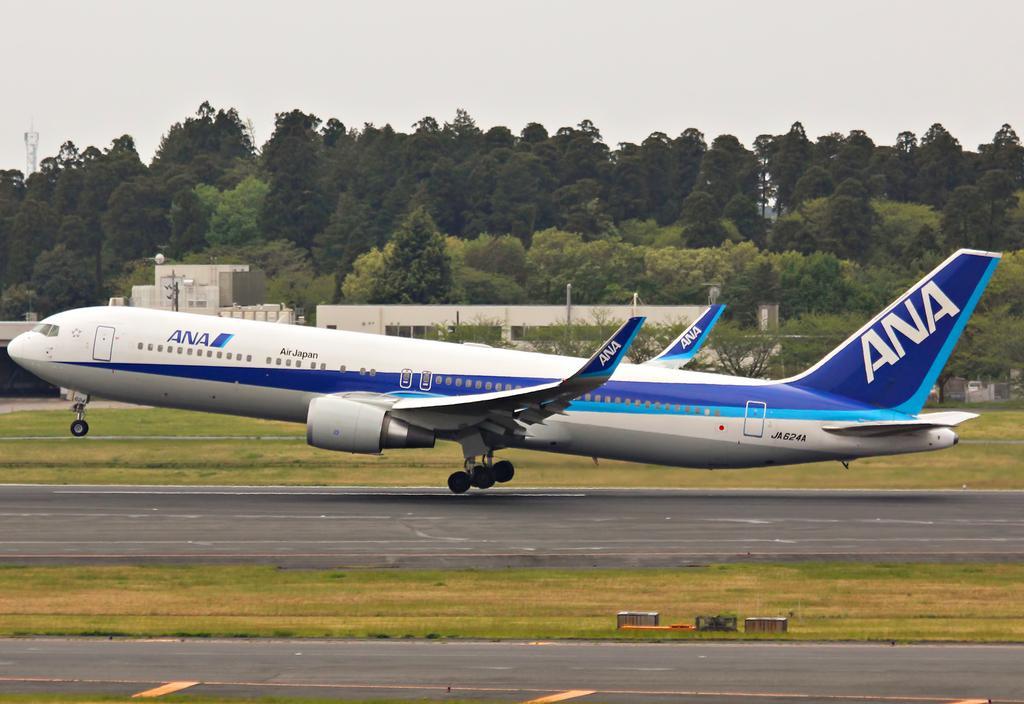How would you summarize this image in a sentence or two? In the center of the image there is a aeroplane. At the bottom of the image there is road. There is grass. In the background of the image there are trees. 